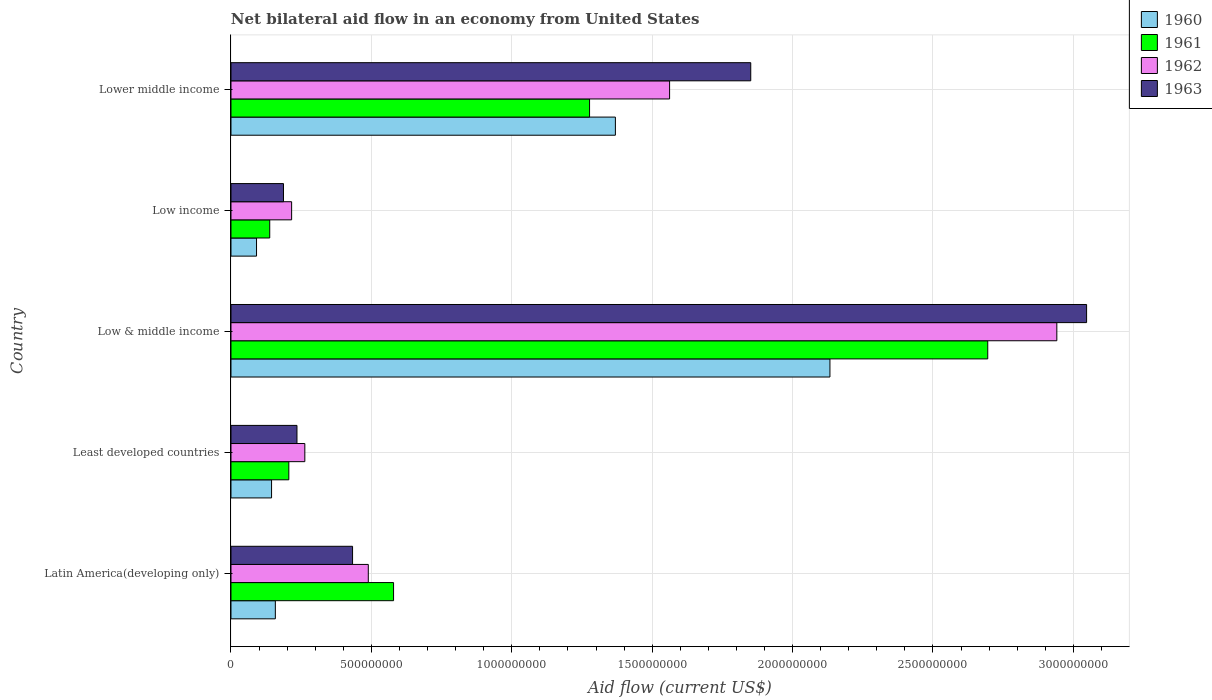How many bars are there on the 2nd tick from the bottom?
Offer a very short reply. 4. What is the label of the 1st group of bars from the top?
Your answer should be compact. Lower middle income. What is the net bilateral aid flow in 1961 in Least developed countries?
Your answer should be compact. 2.06e+08. Across all countries, what is the maximum net bilateral aid flow in 1962?
Provide a short and direct response. 2.94e+09. Across all countries, what is the minimum net bilateral aid flow in 1961?
Your answer should be very brief. 1.38e+08. What is the total net bilateral aid flow in 1962 in the graph?
Offer a very short reply. 5.47e+09. What is the difference between the net bilateral aid flow in 1961 in Latin America(developing only) and that in Least developed countries?
Offer a terse response. 3.73e+08. What is the difference between the net bilateral aid flow in 1963 in Latin America(developing only) and the net bilateral aid flow in 1960 in Low income?
Make the answer very short. 3.42e+08. What is the average net bilateral aid flow in 1960 per country?
Provide a short and direct response. 7.79e+08. What is the difference between the net bilateral aid flow in 1961 and net bilateral aid flow in 1962 in Lower middle income?
Provide a succinct answer. -2.85e+08. In how many countries, is the net bilateral aid flow in 1961 greater than 100000000 US$?
Your answer should be very brief. 5. What is the ratio of the net bilateral aid flow in 1960 in Low & middle income to that in Low income?
Provide a short and direct response. 23.44. Is the net bilateral aid flow in 1960 in Low & middle income less than that in Low income?
Offer a terse response. No. Is the difference between the net bilateral aid flow in 1961 in Latin America(developing only) and Low & middle income greater than the difference between the net bilateral aid flow in 1962 in Latin America(developing only) and Low & middle income?
Keep it short and to the point. Yes. What is the difference between the highest and the second highest net bilateral aid flow in 1962?
Your response must be concise. 1.38e+09. What is the difference between the highest and the lowest net bilateral aid flow in 1961?
Provide a short and direct response. 2.56e+09. In how many countries, is the net bilateral aid flow in 1963 greater than the average net bilateral aid flow in 1963 taken over all countries?
Your response must be concise. 2. What does the 1st bar from the bottom in Lower middle income represents?
Your answer should be very brief. 1960. What is the difference between two consecutive major ticks on the X-axis?
Keep it short and to the point. 5.00e+08. Are the values on the major ticks of X-axis written in scientific E-notation?
Offer a very short reply. No. Does the graph contain any zero values?
Offer a very short reply. No. Does the graph contain grids?
Offer a very short reply. Yes. What is the title of the graph?
Provide a short and direct response. Net bilateral aid flow in an economy from United States. Does "1998" appear as one of the legend labels in the graph?
Ensure brevity in your answer.  No. What is the label or title of the Y-axis?
Keep it short and to the point. Country. What is the Aid flow (current US$) in 1960 in Latin America(developing only)?
Make the answer very short. 1.58e+08. What is the Aid flow (current US$) of 1961 in Latin America(developing only)?
Your response must be concise. 5.79e+08. What is the Aid flow (current US$) of 1962 in Latin America(developing only)?
Offer a terse response. 4.89e+08. What is the Aid flow (current US$) of 1963 in Latin America(developing only)?
Your answer should be very brief. 4.33e+08. What is the Aid flow (current US$) in 1960 in Least developed countries?
Your answer should be compact. 1.45e+08. What is the Aid flow (current US$) of 1961 in Least developed countries?
Your response must be concise. 2.06e+08. What is the Aid flow (current US$) of 1962 in Least developed countries?
Make the answer very short. 2.63e+08. What is the Aid flow (current US$) in 1963 in Least developed countries?
Keep it short and to the point. 2.35e+08. What is the Aid flow (current US$) of 1960 in Low & middle income?
Your answer should be very brief. 2.13e+09. What is the Aid flow (current US$) in 1961 in Low & middle income?
Keep it short and to the point. 2.70e+09. What is the Aid flow (current US$) in 1962 in Low & middle income?
Your response must be concise. 2.94e+09. What is the Aid flow (current US$) of 1963 in Low & middle income?
Your answer should be very brief. 3.05e+09. What is the Aid flow (current US$) of 1960 in Low income?
Your answer should be compact. 9.10e+07. What is the Aid flow (current US$) in 1961 in Low income?
Keep it short and to the point. 1.38e+08. What is the Aid flow (current US$) of 1962 in Low income?
Offer a very short reply. 2.16e+08. What is the Aid flow (current US$) of 1963 in Low income?
Your answer should be compact. 1.87e+08. What is the Aid flow (current US$) in 1960 in Lower middle income?
Offer a very short reply. 1.37e+09. What is the Aid flow (current US$) of 1961 in Lower middle income?
Provide a short and direct response. 1.28e+09. What is the Aid flow (current US$) of 1962 in Lower middle income?
Your answer should be compact. 1.56e+09. What is the Aid flow (current US$) of 1963 in Lower middle income?
Give a very brief answer. 1.85e+09. Across all countries, what is the maximum Aid flow (current US$) of 1960?
Offer a very short reply. 2.13e+09. Across all countries, what is the maximum Aid flow (current US$) in 1961?
Give a very brief answer. 2.70e+09. Across all countries, what is the maximum Aid flow (current US$) in 1962?
Give a very brief answer. 2.94e+09. Across all countries, what is the maximum Aid flow (current US$) of 1963?
Your answer should be compact. 3.05e+09. Across all countries, what is the minimum Aid flow (current US$) in 1960?
Your answer should be very brief. 9.10e+07. Across all countries, what is the minimum Aid flow (current US$) of 1961?
Keep it short and to the point. 1.38e+08. Across all countries, what is the minimum Aid flow (current US$) of 1962?
Your answer should be very brief. 2.16e+08. Across all countries, what is the minimum Aid flow (current US$) of 1963?
Give a very brief answer. 1.87e+08. What is the total Aid flow (current US$) in 1960 in the graph?
Your answer should be very brief. 3.90e+09. What is the total Aid flow (current US$) of 1961 in the graph?
Give a very brief answer. 4.90e+09. What is the total Aid flow (current US$) in 1962 in the graph?
Offer a terse response. 5.47e+09. What is the total Aid flow (current US$) in 1963 in the graph?
Offer a very short reply. 5.75e+09. What is the difference between the Aid flow (current US$) of 1960 in Latin America(developing only) and that in Least developed countries?
Make the answer very short. 1.35e+07. What is the difference between the Aid flow (current US$) of 1961 in Latin America(developing only) and that in Least developed countries?
Provide a short and direct response. 3.73e+08. What is the difference between the Aid flow (current US$) of 1962 in Latin America(developing only) and that in Least developed countries?
Your answer should be very brief. 2.26e+08. What is the difference between the Aid flow (current US$) of 1963 in Latin America(developing only) and that in Least developed countries?
Your answer should be compact. 1.98e+08. What is the difference between the Aid flow (current US$) of 1960 in Latin America(developing only) and that in Low & middle income?
Your answer should be compact. -1.98e+09. What is the difference between the Aid flow (current US$) in 1961 in Latin America(developing only) and that in Low & middle income?
Ensure brevity in your answer.  -2.12e+09. What is the difference between the Aid flow (current US$) in 1962 in Latin America(developing only) and that in Low & middle income?
Offer a very short reply. -2.45e+09. What is the difference between the Aid flow (current US$) of 1963 in Latin America(developing only) and that in Low & middle income?
Give a very brief answer. -2.61e+09. What is the difference between the Aid flow (current US$) in 1960 in Latin America(developing only) and that in Low income?
Your answer should be very brief. 6.70e+07. What is the difference between the Aid flow (current US$) in 1961 in Latin America(developing only) and that in Low income?
Offer a very short reply. 4.41e+08. What is the difference between the Aid flow (current US$) in 1962 in Latin America(developing only) and that in Low income?
Provide a succinct answer. 2.73e+08. What is the difference between the Aid flow (current US$) in 1963 in Latin America(developing only) and that in Low income?
Provide a short and direct response. 2.46e+08. What is the difference between the Aid flow (current US$) of 1960 in Latin America(developing only) and that in Lower middle income?
Keep it short and to the point. -1.21e+09. What is the difference between the Aid flow (current US$) of 1961 in Latin America(developing only) and that in Lower middle income?
Give a very brief answer. -6.98e+08. What is the difference between the Aid flow (current US$) of 1962 in Latin America(developing only) and that in Lower middle income?
Give a very brief answer. -1.07e+09. What is the difference between the Aid flow (current US$) of 1963 in Latin America(developing only) and that in Lower middle income?
Provide a succinct answer. -1.42e+09. What is the difference between the Aid flow (current US$) in 1960 in Least developed countries and that in Low & middle income?
Make the answer very short. -1.99e+09. What is the difference between the Aid flow (current US$) of 1961 in Least developed countries and that in Low & middle income?
Ensure brevity in your answer.  -2.49e+09. What is the difference between the Aid flow (current US$) of 1962 in Least developed countries and that in Low & middle income?
Give a very brief answer. -2.68e+09. What is the difference between the Aid flow (current US$) of 1963 in Least developed countries and that in Low & middle income?
Provide a short and direct response. -2.81e+09. What is the difference between the Aid flow (current US$) in 1960 in Least developed countries and that in Low income?
Your answer should be compact. 5.35e+07. What is the difference between the Aid flow (current US$) in 1961 in Least developed countries and that in Low income?
Keep it short and to the point. 6.80e+07. What is the difference between the Aid flow (current US$) in 1962 in Least developed countries and that in Low income?
Your answer should be very brief. 4.70e+07. What is the difference between the Aid flow (current US$) of 1963 in Least developed countries and that in Low income?
Provide a succinct answer. 4.80e+07. What is the difference between the Aid flow (current US$) of 1960 in Least developed countries and that in Lower middle income?
Offer a very short reply. -1.22e+09. What is the difference between the Aid flow (current US$) in 1961 in Least developed countries and that in Lower middle income?
Make the answer very short. -1.07e+09. What is the difference between the Aid flow (current US$) in 1962 in Least developed countries and that in Lower middle income?
Provide a short and direct response. -1.30e+09. What is the difference between the Aid flow (current US$) in 1963 in Least developed countries and that in Lower middle income?
Give a very brief answer. -1.62e+09. What is the difference between the Aid flow (current US$) in 1960 in Low & middle income and that in Low income?
Keep it short and to the point. 2.04e+09. What is the difference between the Aid flow (current US$) of 1961 in Low & middle income and that in Low income?
Your answer should be compact. 2.56e+09. What is the difference between the Aid flow (current US$) in 1962 in Low & middle income and that in Low income?
Your response must be concise. 2.72e+09. What is the difference between the Aid flow (current US$) of 1963 in Low & middle income and that in Low income?
Your response must be concise. 2.86e+09. What is the difference between the Aid flow (current US$) in 1960 in Low & middle income and that in Lower middle income?
Ensure brevity in your answer.  7.64e+08. What is the difference between the Aid flow (current US$) of 1961 in Low & middle income and that in Lower middle income?
Provide a succinct answer. 1.42e+09. What is the difference between the Aid flow (current US$) of 1962 in Low & middle income and that in Lower middle income?
Make the answer very short. 1.38e+09. What is the difference between the Aid flow (current US$) of 1963 in Low & middle income and that in Lower middle income?
Your response must be concise. 1.20e+09. What is the difference between the Aid flow (current US$) in 1960 in Low income and that in Lower middle income?
Keep it short and to the point. -1.28e+09. What is the difference between the Aid flow (current US$) of 1961 in Low income and that in Lower middle income?
Keep it short and to the point. -1.14e+09. What is the difference between the Aid flow (current US$) of 1962 in Low income and that in Lower middle income?
Make the answer very short. -1.35e+09. What is the difference between the Aid flow (current US$) in 1963 in Low income and that in Lower middle income?
Your answer should be compact. -1.66e+09. What is the difference between the Aid flow (current US$) of 1960 in Latin America(developing only) and the Aid flow (current US$) of 1961 in Least developed countries?
Provide a succinct answer. -4.80e+07. What is the difference between the Aid flow (current US$) of 1960 in Latin America(developing only) and the Aid flow (current US$) of 1962 in Least developed countries?
Ensure brevity in your answer.  -1.05e+08. What is the difference between the Aid flow (current US$) in 1960 in Latin America(developing only) and the Aid flow (current US$) in 1963 in Least developed countries?
Offer a terse response. -7.70e+07. What is the difference between the Aid flow (current US$) in 1961 in Latin America(developing only) and the Aid flow (current US$) in 1962 in Least developed countries?
Provide a short and direct response. 3.16e+08. What is the difference between the Aid flow (current US$) of 1961 in Latin America(developing only) and the Aid flow (current US$) of 1963 in Least developed countries?
Your answer should be very brief. 3.44e+08. What is the difference between the Aid flow (current US$) of 1962 in Latin America(developing only) and the Aid flow (current US$) of 1963 in Least developed countries?
Offer a terse response. 2.54e+08. What is the difference between the Aid flow (current US$) in 1960 in Latin America(developing only) and the Aid flow (current US$) in 1961 in Low & middle income?
Your answer should be very brief. -2.54e+09. What is the difference between the Aid flow (current US$) of 1960 in Latin America(developing only) and the Aid flow (current US$) of 1962 in Low & middle income?
Give a very brief answer. -2.78e+09. What is the difference between the Aid flow (current US$) of 1960 in Latin America(developing only) and the Aid flow (current US$) of 1963 in Low & middle income?
Provide a short and direct response. -2.89e+09. What is the difference between the Aid flow (current US$) of 1961 in Latin America(developing only) and the Aid flow (current US$) of 1962 in Low & middle income?
Your response must be concise. -2.36e+09. What is the difference between the Aid flow (current US$) of 1961 in Latin America(developing only) and the Aid flow (current US$) of 1963 in Low & middle income?
Keep it short and to the point. -2.47e+09. What is the difference between the Aid flow (current US$) in 1962 in Latin America(developing only) and the Aid flow (current US$) in 1963 in Low & middle income?
Your answer should be very brief. -2.56e+09. What is the difference between the Aid flow (current US$) in 1960 in Latin America(developing only) and the Aid flow (current US$) in 1961 in Low income?
Keep it short and to the point. 2.00e+07. What is the difference between the Aid flow (current US$) of 1960 in Latin America(developing only) and the Aid flow (current US$) of 1962 in Low income?
Your response must be concise. -5.80e+07. What is the difference between the Aid flow (current US$) of 1960 in Latin America(developing only) and the Aid flow (current US$) of 1963 in Low income?
Offer a very short reply. -2.90e+07. What is the difference between the Aid flow (current US$) in 1961 in Latin America(developing only) and the Aid flow (current US$) in 1962 in Low income?
Provide a short and direct response. 3.63e+08. What is the difference between the Aid flow (current US$) in 1961 in Latin America(developing only) and the Aid flow (current US$) in 1963 in Low income?
Your response must be concise. 3.92e+08. What is the difference between the Aid flow (current US$) of 1962 in Latin America(developing only) and the Aid flow (current US$) of 1963 in Low income?
Give a very brief answer. 3.02e+08. What is the difference between the Aid flow (current US$) of 1960 in Latin America(developing only) and the Aid flow (current US$) of 1961 in Lower middle income?
Provide a succinct answer. -1.12e+09. What is the difference between the Aid flow (current US$) of 1960 in Latin America(developing only) and the Aid flow (current US$) of 1962 in Lower middle income?
Your response must be concise. -1.40e+09. What is the difference between the Aid flow (current US$) of 1960 in Latin America(developing only) and the Aid flow (current US$) of 1963 in Lower middle income?
Keep it short and to the point. -1.69e+09. What is the difference between the Aid flow (current US$) in 1961 in Latin America(developing only) and the Aid flow (current US$) in 1962 in Lower middle income?
Offer a terse response. -9.83e+08. What is the difference between the Aid flow (current US$) of 1961 in Latin America(developing only) and the Aid flow (current US$) of 1963 in Lower middle income?
Offer a very short reply. -1.27e+09. What is the difference between the Aid flow (current US$) in 1962 in Latin America(developing only) and the Aid flow (current US$) in 1963 in Lower middle income?
Ensure brevity in your answer.  -1.36e+09. What is the difference between the Aid flow (current US$) in 1960 in Least developed countries and the Aid flow (current US$) in 1961 in Low & middle income?
Your response must be concise. -2.55e+09. What is the difference between the Aid flow (current US$) of 1960 in Least developed countries and the Aid flow (current US$) of 1962 in Low & middle income?
Give a very brief answer. -2.80e+09. What is the difference between the Aid flow (current US$) of 1960 in Least developed countries and the Aid flow (current US$) of 1963 in Low & middle income?
Keep it short and to the point. -2.90e+09. What is the difference between the Aid flow (current US$) in 1961 in Least developed countries and the Aid flow (current US$) in 1962 in Low & middle income?
Offer a very short reply. -2.74e+09. What is the difference between the Aid flow (current US$) in 1961 in Least developed countries and the Aid flow (current US$) in 1963 in Low & middle income?
Give a very brief answer. -2.84e+09. What is the difference between the Aid flow (current US$) of 1962 in Least developed countries and the Aid flow (current US$) of 1963 in Low & middle income?
Make the answer very short. -2.78e+09. What is the difference between the Aid flow (current US$) in 1960 in Least developed countries and the Aid flow (current US$) in 1961 in Low income?
Provide a short and direct response. 6.52e+06. What is the difference between the Aid flow (current US$) in 1960 in Least developed countries and the Aid flow (current US$) in 1962 in Low income?
Keep it short and to the point. -7.15e+07. What is the difference between the Aid flow (current US$) of 1960 in Least developed countries and the Aid flow (current US$) of 1963 in Low income?
Your response must be concise. -4.25e+07. What is the difference between the Aid flow (current US$) in 1961 in Least developed countries and the Aid flow (current US$) in 1962 in Low income?
Your answer should be compact. -1.00e+07. What is the difference between the Aid flow (current US$) in 1961 in Least developed countries and the Aid flow (current US$) in 1963 in Low income?
Offer a terse response. 1.90e+07. What is the difference between the Aid flow (current US$) in 1962 in Least developed countries and the Aid flow (current US$) in 1963 in Low income?
Your answer should be compact. 7.60e+07. What is the difference between the Aid flow (current US$) in 1960 in Least developed countries and the Aid flow (current US$) in 1961 in Lower middle income?
Your answer should be compact. -1.13e+09. What is the difference between the Aid flow (current US$) of 1960 in Least developed countries and the Aid flow (current US$) of 1962 in Lower middle income?
Keep it short and to the point. -1.42e+09. What is the difference between the Aid flow (current US$) in 1960 in Least developed countries and the Aid flow (current US$) in 1963 in Lower middle income?
Keep it short and to the point. -1.71e+09. What is the difference between the Aid flow (current US$) in 1961 in Least developed countries and the Aid flow (current US$) in 1962 in Lower middle income?
Provide a short and direct response. -1.36e+09. What is the difference between the Aid flow (current US$) in 1961 in Least developed countries and the Aid flow (current US$) in 1963 in Lower middle income?
Your answer should be compact. -1.64e+09. What is the difference between the Aid flow (current US$) of 1962 in Least developed countries and the Aid flow (current US$) of 1963 in Lower middle income?
Your answer should be compact. -1.59e+09. What is the difference between the Aid flow (current US$) in 1960 in Low & middle income and the Aid flow (current US$) in 1961 in Low income?
Ensure brevity in your answer.  2.00e+09. What is the difference between the Aid flow (current US$) of 1960 in Low & middle income and the Aid flow (current US$) of 1962 in Low income?
Your response must be concise. 1.92e+09. What is the difference between the Aid flow (current US$) of 1960 in Low & middle income and the Aid flow (current US$) of 1963 in Low income?
Your answer should be very brief. 1.95e+09. What is the difference between the Aid flow (current US$) in 1961 in Low & middle income and the Aid flow (current US$) in 1962 in Low income?
Make the answer very short. 2.48e+09. What is the difference between the Aid flow (current US$) in 1961 in Low & middle income and the Aid flow (current US$) in 1963 in Low income?
Make the answer very short. 2.51e+09. What is the difference between the Aid flow (current US$) in 1962 in Low & middle income and the Aid flow (current US$) in 1963 in Low income?
Keep it short and to the point. 2.75e+09. What is the difference between the Aid flow (current US$) of 1960 in Low & middle income and the Aid flow (current US$) of 1961 in Lower middle income?
Offer a terse response. 8.56e+08. What is the difference between the Aid flow (current US$) of 1960 in Low & middle income and the Aid flow (current US$) of 1962 in Lower middle income?
Your answer should be compact. 5.71e+08. What is the difference between the Aid flow (current US$) of 1960 in Low & middle income and the Aid flow (current US$) of 1963 in Lower middle income?
Your answer should be compact. 2.82e+08. What is the difference between the Aid flow (current US$) in 1961 in Low & middle income and the Aid flow (current US$) in 1962 in Lower middle income?
Offer a very short reply. 1.13e+09. What is the difference between the Aid flow (current US$) in 1961 in Low & middle income and the Aid flow (current US$) in 1963 in Lower middle income?
Offer a very short reply. 8.44e+08. What is the difference between the Aid flow (current US$) in 1962 in Low & middle income and the Aid flow (current US$) in 1963 in Lower middle income?
Offer a very short reply. 1.09e+09. What is the difference between the Aid flow (current US$) of 1960 in Low income and the Aid flow (current US$) of 1961 in Lower middle income?
Your answer should be compact. -1.19e+09. What is the difference between the Aid flow (current US$) of 1960 in Low income and the Aid flow (current US$) of 1962 in Lower middle income?
Offer a terse response. -1.47e+09. What is the difference between the Aid flow (current US$) in 1960 in Low income and the Aid flow (current US$) in 1963 in Lower middle income?
Give a very brief answer. -1.76e+09. What is the difference between the Aid flow (current US$) of 1961 in Low income and the Aid flow (current US$) of 1962 in Lower middle income?
Make the answer very short. -1.42e+09. What is the difference between the Aid flow (current US$) in 1961 in Low income and the Aid flow (current US$) in 1963 in Lower middle income?
Provide a succinct answer. -1.71e+09. What is the difference between the Aid flow (current US$) of 1962 in Low income and the Aid flow (current US$) of 1963 in Lower middle income?
Your answer should be compact. -1.64e+09. What is the average Aid flow (current US$) of 1960 per country?
Give a very brief answer. 7.79e+08. What is the average Aid flow (current US$) in 1961 per country?
Your answer should be very brief. 9.79e+08. What is the average Aid flow (current US$) of 1962 per country?
Provide a succinct answer. 1.09e+09. What is the average Aid flow (current US$) in 1963 per country?
Give a very brief answer. 1.15e+09. What is the difference between the Aid flow (current US$) of 1960 and Aid flow (current US$) of 1961 in Latin America(developing only)?
Your answer should be very brief. -4.21e+08. What is the difference between the Aid flow (current US$) in 1960 and Aid flow (current US$) in 1962 in Latin America(developing only)?
Your answer should be very brief. -3.31e+08. What is the difference between the Aid flow (current US$) in 1960 and Aid flow (current US$) in 1963 in Latin America(developing only)?
Make the answer very short. -2.75e+08. What is the difference between the Aid flow (current US$) of 1961 and Aid flow (current US$) of 1962 in Latin America(developing only)?
Your answer should be very brief. 9.00e+07. What is the difference between the Aid flow (current US$) in 1961 and Aid flow (current US$) in 1963 in Latin America(developing only)?
Your response must be concise. 1.46e+08. What is the difference between the Aid flow (current US$) of 1962 and Aid flow (current US$) of 1963 in Latin America(developing only)?
Your answer should be very brief. 5.60e+07. What is the difference between the Aid flow (current US$) in 1960 and Aid flow (current US$) in 1961 in Least developed countries?
Provide a short and direct response. -6.15e+07. What is the difference between the Aid flow (current US$) of 1960 and Aid flow (current US$) of 1962 in Least developed countries?
Ensure brevity in your answer.  -1.18e+08. What is the difference between the Aid flow (current US$) in 1960 and Aid flow (current US$) in 1963 in Least developed countries?
Keep it short and to the point. -9.05e+07. What is the difference between the Aid flow (current US$) of 1961 and Aid flow (current US$) of 1962 in Least developed countries?
Offer a very short reply. -5.70e+07. What is the difference between the Aid flow (current US$) of 1961 and Aid flow (current US$) of 1963 in Least developed countries?
Your answer should be compact. -2.90e+07. What is the difference between the Aid flow (current US$) in 1962 and Aid flow (current US$) in 1963 in Least developed countries?
Your answer should be compact. 2.80e+07. What is the difference between the Aid flow (current US$) in 1960 and Aid flow (current US$) in 1961 in Low & middle income?
Ensure brevity in your answer.  -5.62e+08. What is the difference between the Aid flow (current US$) in 1960 and Aid flow (current US$) in 1962 in Low & middle income?
Ensure brevity in your answer.  -8.08e+08. What is the difference between the Aid flow (current US$) in 1960 and Aid flow (current US$) in 1963 in Low & middle income?
Make the answer very short. -9.14e+08. What is the difference between the Aid flow (current US$) in 1961 and Aid flow (current US$) in 1962 in Low & middle income?
Your answer should be very brief. -2.46e+08. What is the difference between the Aid flow (current US$) of 1961 and Aid flow (current US$) of 1963 in Low & middle income?
Provide a short and direct response. -3.52e+08. What is the difference between the Aid flow (current US$) in 1962 and Aid flow (current US$) in 1963 in Low & middle income?
Keep it short and to the point. -1.06e+08. What is the difference between the Aid flow (current US$) of 1960 and Aid flow (current US$) of 1961 in Low income?
Ensure brevity in your answer.  -4.70e+07. What is the difference between the Aid flow (current US$) in 1960 and Aid flow (current US$) in 1962 in Low income?
Give a very brief answer. -1.25e+08. What is the difference between the Aid flow (current US$) in 1960 and Aid flow (current US$) in 1963 in Low income?
Provide a short and direct response. -9.60e+07. What is the difference between the Aid flow (current US$) of 1961 and Aid flow (current US$) of 1962 in Low income?
Your response must be concise. -7.80e+07. What is the difference between the Aid flow (current US$) in 1961 and Aid flow (current US$) in 1963 in Low income?
Make the answer very short. -4.90e+07. What is the difference between the Aid flow (current US$) in 1962 and Aid flow (current US$) in 1963 in Low income?
Offer a very short reply. 2.90e+07. What is the difference between the Aid flow (current US$) in 1960 and Aid flow (current US$) in 1961 in Lower middle income?
Offer a very short reply. 9.20e+07. What is the difference between the Aid flow (current US$) of 1960 and Aid flow (current US$) of 1962 in Lower middle income?
Provide a short and direct response. -1.93e+08. What is the difference between the Aid flow (current US$) in 1960 and Aid flow (current US$) in 1963 in Lower middle income?
Your response must be concise. -4.82e+08. What is the difference between the Aid flow (current US$) of 1961 and Aid flow (current US$) of 1962 in Lower middle income?
Provide a succinct answer. -2.85e+08. What is the difference between the Aid flow (current US$) in 1961 and Aid flow (current US$) in 1963 in Lower middle income?
Ensure brevity in your answer.  -5.74e+08. What is the difference between the Aid flow (current US$) of 1962 and Aid flow (current US$) of 1963 in Lower middle income?
Keep it short and to the point. -2.89e+08. What is the ratio of the Aid flow (current US$) of 1960 in Latin America(developing only) to that in Least developed countries?
Offer a terse response. 1.09. What is the ratio of the Aid flow (current US$) of 1961 in Latin America(developing only) to that in Least developed countries?
Your answer should be compact. 2.81. What is the ratio of the Aid flow (current US$) in 1962 in Latin America(developing only) to that in Least developed countries?
Give a very brief answer. 1.86. What is the ratio of the Aid flow (current US$) of 1963 in Latin America(developing only) to that in Least developed countries?
Your answer should be very brief. 1.84. What is the ratio of the Aid flow (current US$) of 1960 in Latin America(developing only) to that in Low & middle income?
Provide a succinct answer. 0.07. What is the ratio of the Aid flow (current US$) of 1961 in Latin America(developing only) to that in Low & middle income?
Offer a very short reply. 0.21. What is the ratio of the Aid flow (current US$) in 1962 in Latin America(developing only) to that in Low & middle income?
Offer a terse response. 0.17. What is the ratio of the Aid flow (current US$) of 1963 in Latin America(developing only) to that in Low & middle income?
Your answer should be compact. 0.14. What is the ratio of the Aid flow (current US$) of 1960 in Latin America(developing only) to that in Low income?
Provide a succinct answer. 1.74. What is the ratio of the Aid flow (current US$) of 1961 in Latin America(developing only) to that in Low income?
Your answer should be very brief. 4.2. What is the ratio of the Aid flow (current US$) in 1962 in Latin America(developing only) to that in Low income?
Keep it short and to the point. 2.26. What is the ratio of the Aid flow (current US$) in 1963 in Latin America(developing only) to that in Low income?
Make the answer very short. 2.32. What is the ratio of the Aid flow (current US$) in 1960 in Latin America(developing only) to that in Lower middle income?
Make the answer very short. 0.12. What is the ratio of the Aid flow (current US$) of 1961 in Latin America(developing only) to that in Lower middle income?
Make the answer very short. 0.45. What is the ratio of the Aid flow (current US$) of 1962 in Latin America(developing only) to that in Lower middle income?
Offer a very short reply. 0.31. What is the ratio of the Aid flow (current US$) of 1963 in Latin America(developing only) to that in Lower middle income?
Your answer should be very brief. 0.23. What is the ratio of the Aid flow (current US$) of 1960 in Least developed countries to that in Low & middle income?
Ensure brevity in your answer.  0.07. What is the ratio of the Aid flow (current US$) in 1961 in Least developed countries to that in Low & middle income?
Keep it short and to the point. 0.08. What is the ratio of the Aid flow (current US$) in 1962 in Least developed countries to that in Low & middle income?
Your answer should be compact. 0.09. What is the ratio of the Aid flow (current US$) of 1963 in Least developed countries to that in Low & middle income?
Provide a short and direct response. 0.08. What is the ratio of the Aid flow (current US$) in 1960 in Least developed countries to that in Low income?
Keep it short and to the point. 1.59. What is the ratio of the Aid flow (current US$) of 1961 in Least developed countries to that in Low income?
Make the answer very short. 1.49. What is the ratio of the Aid flow (current US$) in 1962 in Least developed countries to that in Low income?
Offer a terse response. 1.22. What is the ratio of the Aid flow (current US$) of 1963 in Least developed countries to that in Low income?
Your answer should be compact. 1.26. What is the ratio of the Aid flow (current US$) of 1960 in Least developed countries to that in Lower middle income?
Keep it short and to the point. 0.11. What is the ratio of the Aid flow (current US$) in 1961 in Least developed countries to that in Lower middle income?
Provide a succinct answer. 0.16. What is the ratio of the Aid flow (current US$) in 1962 in Least developed countries to that in Lower middle income?
Offer a very short reply. 0.17. What is the ratio of the Aid flow (current US$) in 1963 in Least developed countries to that in Lower middle income?
Ensure brevity in your answer.  0.13. What is the ratio of the Aid flow (current US$) in 1960 in Low & middle income to that in Low income?
Give a very brief answer. 23.44. What is the ratio of the Aid flow (current US$) of 1961 in Low & middle income to that in Low income?
Make the answer very short. 19.53. What is the ratio of the Aid flow (current US$) of 1962 in Low & middle income to that in Low income?
Your answer should be very brief. 13.62. What is the ratio of the Aid flow (current US$) in 1963 in Low & middle income to that in Low income?
Make the answer very short. 16.29. What is the ratio of the Aid flow (current US$) in 1960 in Low & middle income to that in Lower middle income?
Give a very brief answer. 1.56. What is the ratio of the Aid flow (current US$) of 1961 in Low & middle income to that in Lower middle income?
Provide a succinct answer. 2.11. What is the ratio of the Aid flow (current US$) in 1962 in Low & middle income to that in Lower middle income?
Ensure brevity in your answer.  1.88. What is the ratio of the Aid flow (current US$) of 1963 in Low & middle income to that in Lower middle income?
Keep it short and to the point. 1.65. What is the ratio of the Aid flow (current US$) in 1960 in Low income to that in Lower middle income?
Ensure brevity in your answer.  0.07. What is the ratio of the Aid flow (current US$) of 1961 in Low income to that in Lower middle income?
Provide a short and direct response. 0.11. What is the ratio of the Aid flow (current US$) of 1962 in Low income to that in Lower middle income?
Ensure brevity in your answer.  0.14. What is the ratio of the Aid flow (current US$) of 1963 in Low income to that in Lower middle income?
Offer a very short reply. 0.1. What is the difference between the highest and the second highest Aid flow (current US$) of 1960?
Provide a succinct answer. 7.64e+08. What is the difference between the highest and the second highest Aid flow (current US$) of 1961?
Offer a very short reply. 1.42e+09. What is the difference between the highest and the second highest Aid flow (current US$) of 1962?
Keep it short and to the point. 1.38e+09. What is the difference between the highest and the second highest Aid flow (current US$) in 1963?
Keep it short and to the point. 1.20e+09. What is the difference between the highest and the lowest Aid flow (current US$) of 1960?
Provide a succinct answer. 2.04e+09. What is the difference between the highest and the lowest Aid flow (current US$) in 1961?
Make the answer very short. 2.56e+09. What is the difference between the highest and the lowest Aid flow (current US$) in 1962?
Offer a very short reply. 2.72e+09. What is the difference between the highest and the lowest Aid flow (current US$) of 1963?
Provide a succinct answer. 2.86e+09. 